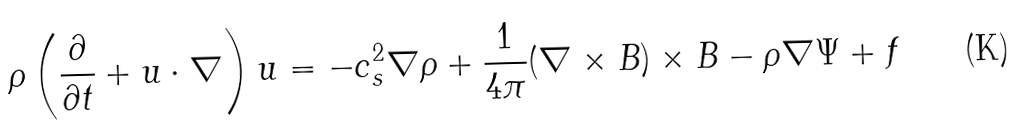Convert formula to latex. <formula><loc_0><loc_0><loc_500><loc_500>\rho \left ( \frac { \partial } { \partial t } + u \cdot \nabla \right ) u = - c _ { s } ^ { 2 } \nabla \rho + \frac { 1 } { 4 \pi } ( \nabla \times B ) \times B - \rho \nabla \Psi + f</formula> 